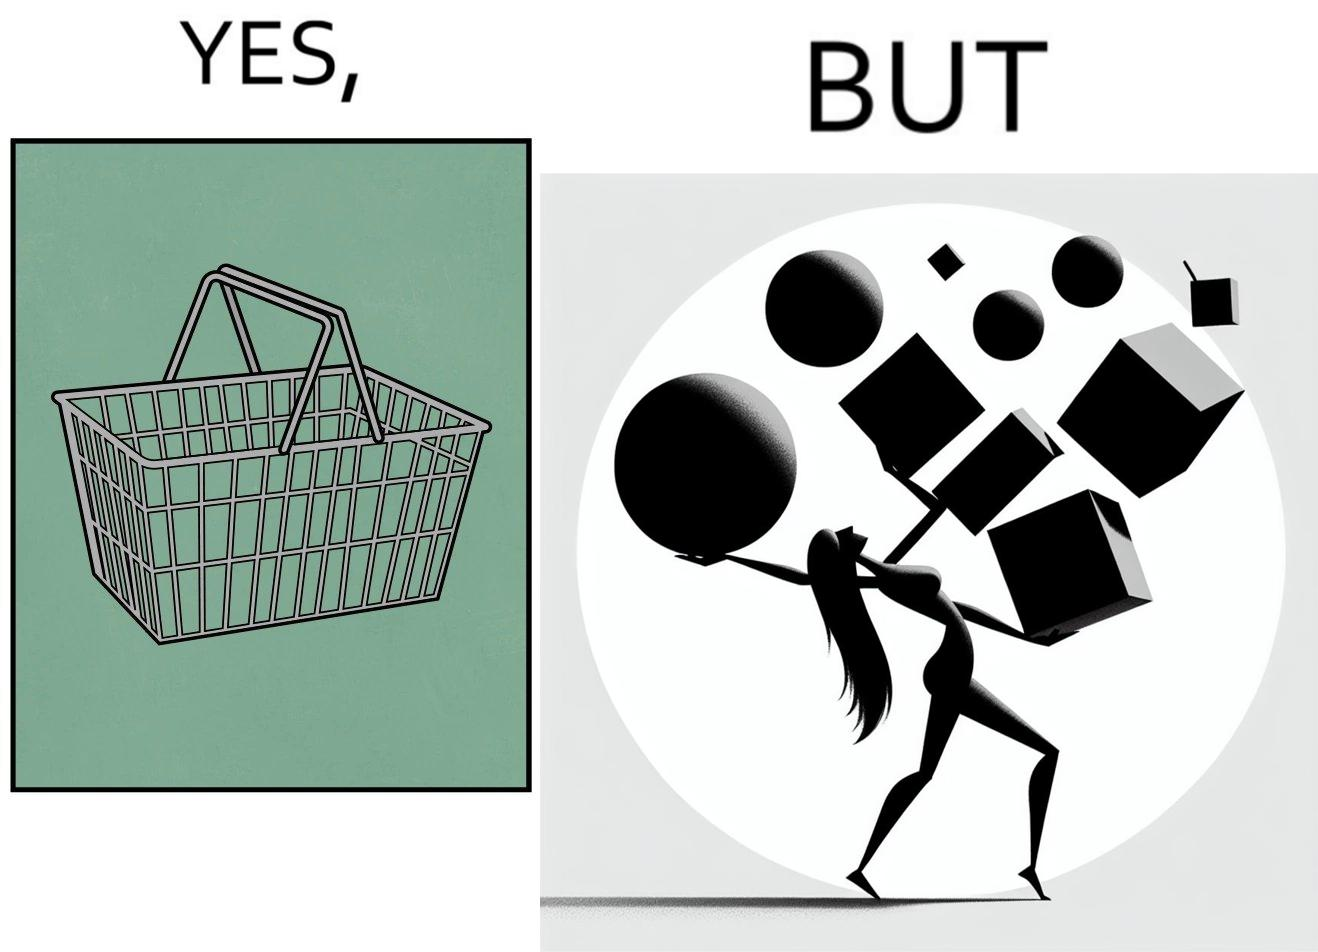Describe the satirical element in this image. The image is ironic, because even when there are steel frame baskets are available at the supermarkets people prefer carrying the items in hand 